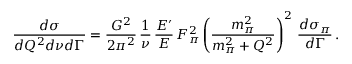Convert formula to latex. <formula><loc_0><loc_0><loc_500><loc_500>\frac { d \sigma } { d Q ^ { 2 } d \nu d \Gamma } = \frac { G ^ { 2 } } { 2 \pi ^ { 2 } } \, \frac { 1 } { \nu } \, \frac { E ^ { \prime } } { E } \, F _ { \pi } ^ { 2 } \left ( \frac { m _ { \pi } ^ { 2 } } { m _ { \pi } ^ { 2 } + Q ^ { 2 } } \right ) ^ { 2 } \, \frac { d \sigma _ { \pi } } { d \Gamma } \, .</formula> 